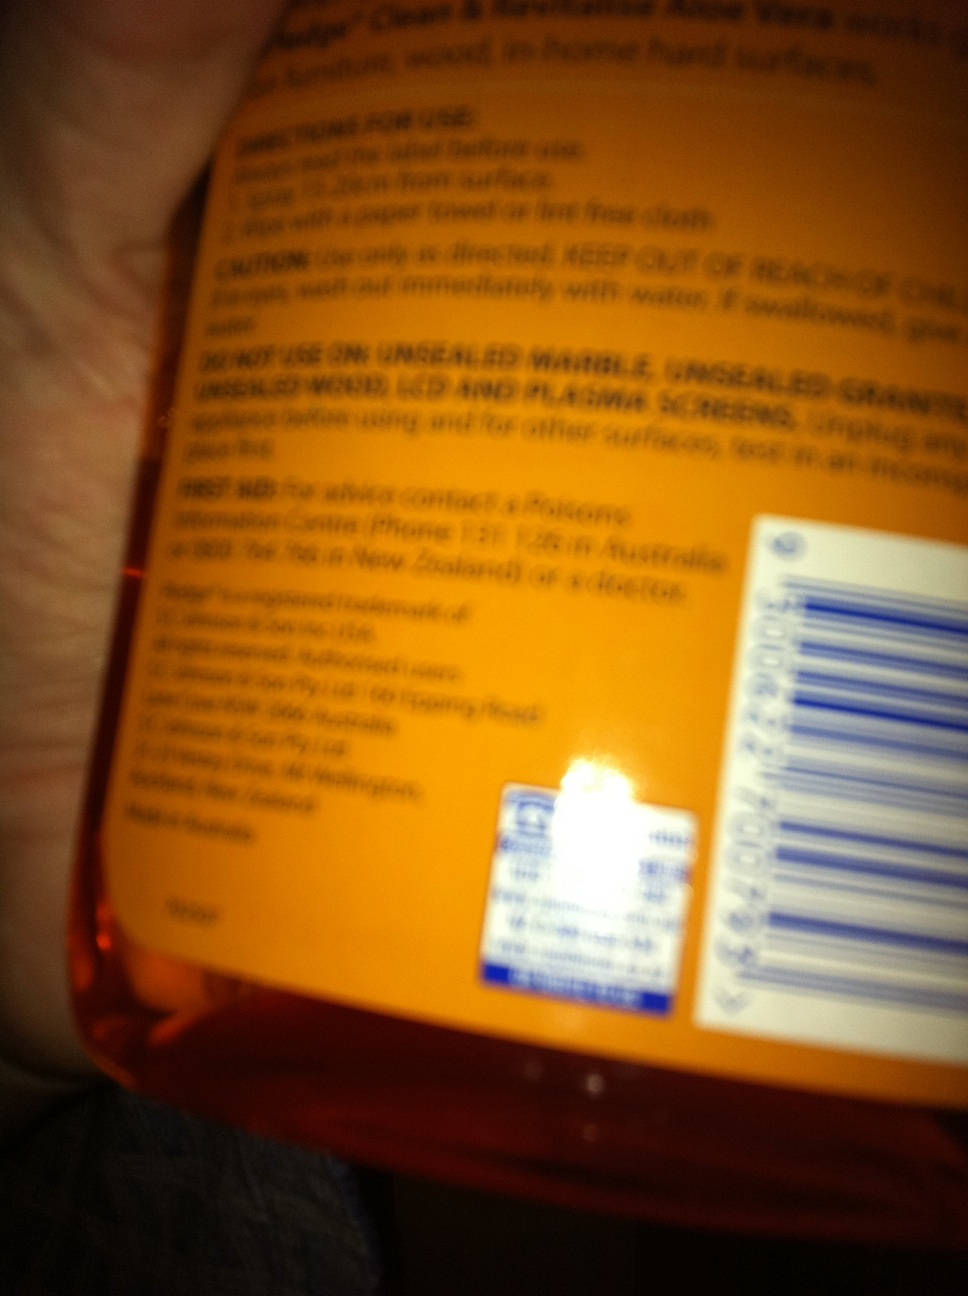What precautions should be taken when using this product? Precautions include using the product only as directed, ensuring that it doesn’t come in contact with eyes or skin, and keeping it out of reach of children. It's also important not to mix it with other cleaning agents to prevent chemical reactions. What should someone do if they accidentally ingest some of this product? In case of accidental ingestion, the label advises rinsing the mouth immediately with water and seeking medical advice promptly. It emphasizes not inducing vomiting unless specifically instructed by medical personnel. 